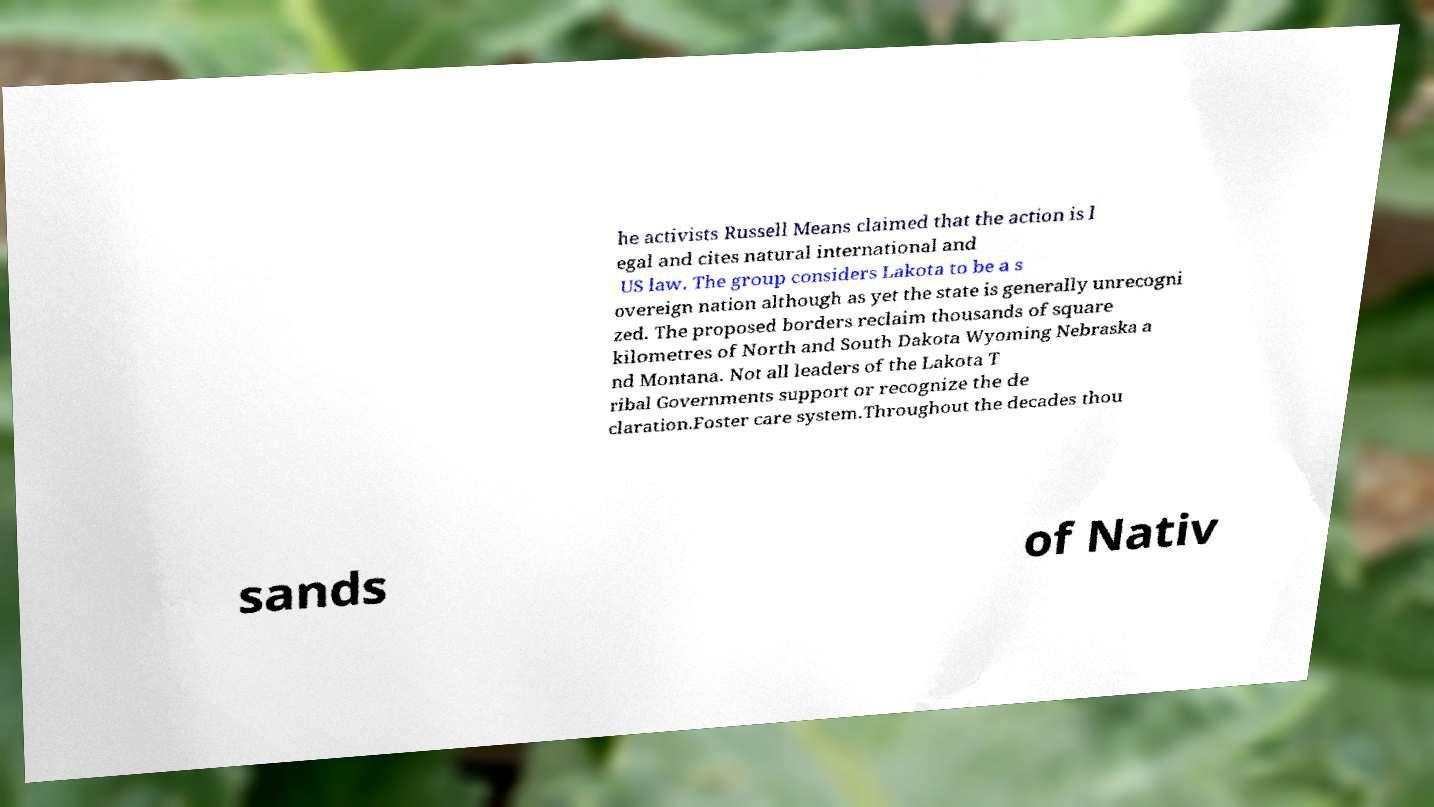Can you accurately transcribe the text from the provided image for me? he activists Russell Means claimed that the action is l egal and cites natural international and US law. The group considers Lakota to be a s overeign nation although as yet the state is generally unrecogni zed. The proposed borders reclaim thousands of square kilometres of North and South Dakota Wyoming Nebraska a nd Montana. Not all leaders of the Lakota T ribal Governments support or recognize the de claration.Foster care system.Throughout the decades thou sands of Nativ 